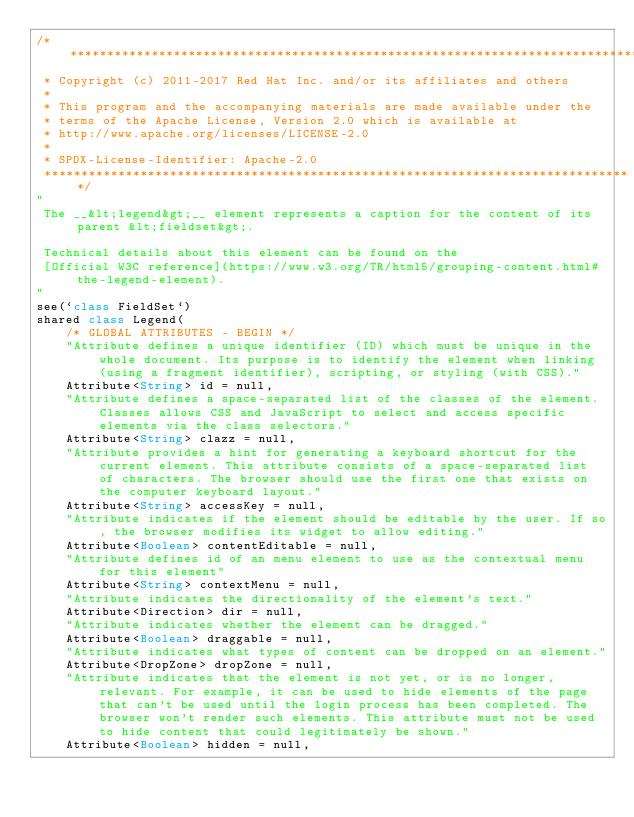<code> <loc_0><loc_0><loc_500><loc_500><_Ceylon_>/********************************************************************************
 * Copyright (c) 2011-2017 Red Hat Inc. and/or its affiliates and others
 *
 * This program and the accompanying materials are made available under the 
 * terms of the Apache License, Version 2.0 which is available at
 * http://www.apache.org/licenses/LICENSE-2.0
 *
 * SPDX-License-Identifier: Apache-2.0 
 ********************************************************************************/
"
 The __&lt;legend&gt;__ element represents a caption for the content of its parent &lt;fieldset&gt;.
 
 Technical details about this element can be found on the
 [Official W3C reference](https://www.w3.org/TR/html5/grouping-content.html#the-legend-element).
"
see(`class FieldSet`)
shared class Legend(
    /* GLOBAL ATTRIBUTES - BEGIN */
    "Attribute defines a unique identifier (ID) which must be unique in the whole document. Its purpose is to identify the element when linking (using a fragment identifier), scripting, or styling (with CSS)."
    Attribute<String> id = null,
    "Attribute defines a space-separated list of the classes of the element. Classes allows CSS and JavaScript to select and access specific elements via the class selectors."
    Attribute<String> clazz = null,
    "Attribute provides a hint for generating a keyboard shortcut for the current element. This attribute consists of a space-separated list of characters. The browser should use the first one that exists on the computer keyboard layout."
    Attribute<String> accessKey = null,
    "Attribute indicates if the element should be editable by the user. If so, the browser modifies its widget to allow editing."
    Attribute<Boolean> contentEditable = null,
    "Attribute defines id of an menu element to use as the contextual menu for this element"
    Attribute<String> contextMenu = null,
    "Attribute indicates the directionality of the element's text."
    Attribute<Direction> dir = null,
    "Attribute indicates whether the element can be dragged."
    Attribute<Boolean> draggable = null,
    "Attribute indicates what types of content can be dropped on an element."
    Attribute<DropZone> dropZone = null,
    "Attribute indicates that the element is not yet, or is no longer, relevant. For example, it can be used to hide elements of the page that can't be used until the login process has been completed. The browser won't render such elements. This attribute must not be used to hide content that could legitimately be shown."
    Attribute<Boolean> hidden = null,</code> 